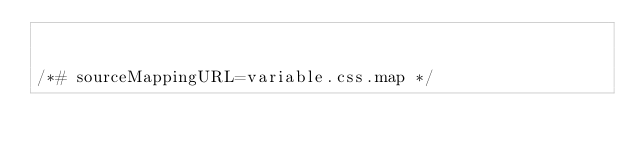Convert code to text. <code><loc_0><loc_0><loc_500><loc_500><_CSS_>

/*# sourceMappingURL=variable.css.map */
</code> 